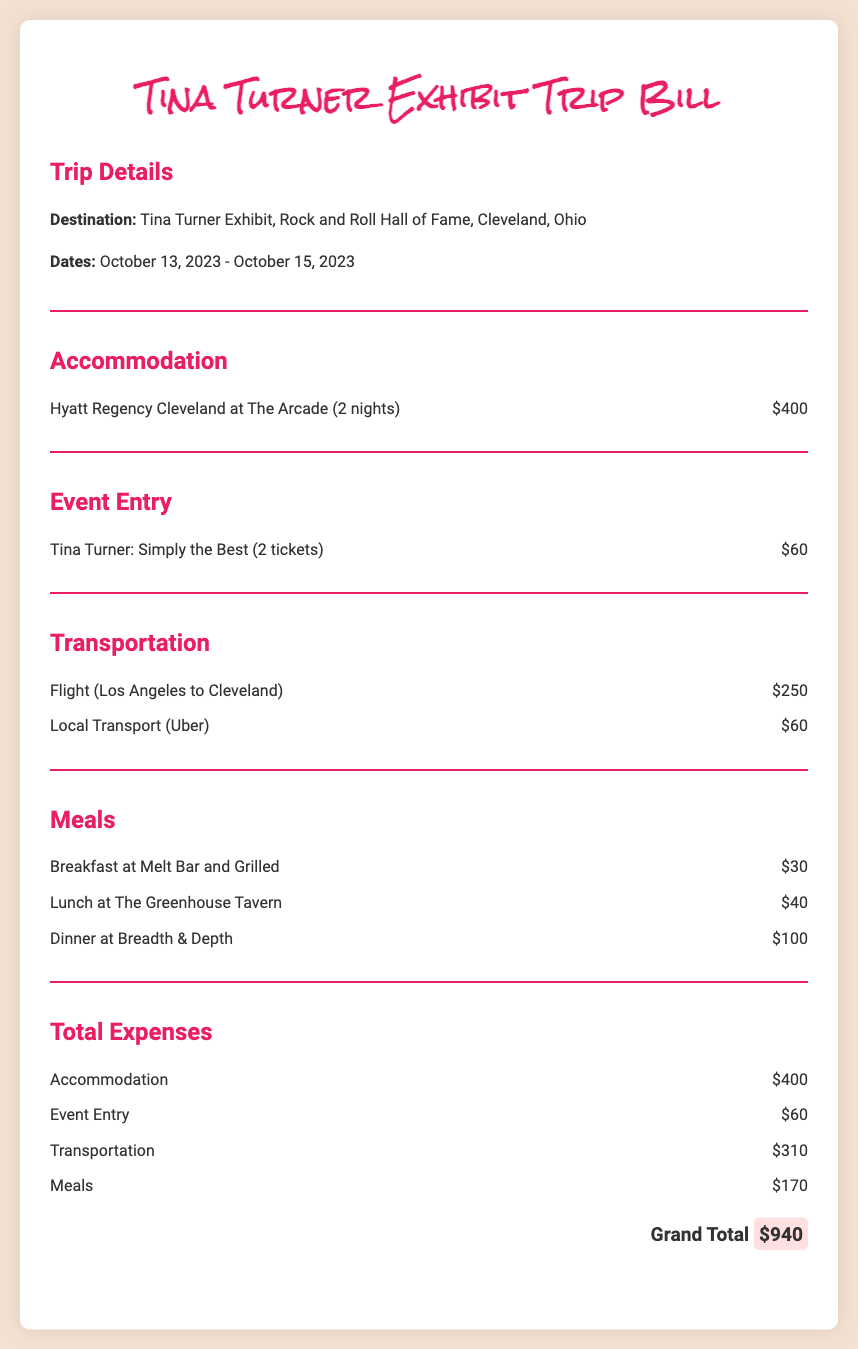What is the destination of the trip? The destination is mentioned in the Trip Details section as the Tina Turner Exhibit at the Rock and Roll Hall of Fame in Cleveland, Ohio.
Answer: Tina Turner Exhibit, Rock and Roll Hall of Fame, Cleveland, Ohio What are the dates of the trip? The dates of the trip are specified in the Trip Details section as October 13, 2023 - October 15, 2023.
Answer: October 13, 2023 - October 15, 2023 How much is the accommodation for two nights? The cost of accommodation is listed in the Accommodation section as $400 for two nights.
Answer: $400 How many tickets were purchased for the event? The number of tickets for the event is provided in the Event Entry section, stating 2 tickets were purchased.
Answer: 2 tickets What is the total cost of transportation? The total cost of transportation is calculated by adding the costs associated with the flight and local transport, which is $250 + $60 = $310.
Answer: $310 What is the total amount spent on meals? The total amount spent on meals is the sum of the individual meal costs, which totals $30 + $40 + $100 = $170.
Answer: $170 What is the grand total for the trip expenses? The grand total is clearly stated in the Total Expenses section, summarizing all expenses to $940.
Answer: $940 Which hotel was chosen for accommodation? The hotel for accommodation is mentioned in the Accommodation section as Hyatt Regency Cleveland at The Arcade.
Answer: Hyatt Regency Cleveland at The Arcade What was the cost of local transport? The cost of local transport is specifically listed in the Transportation section as $60.
Answer: $60 